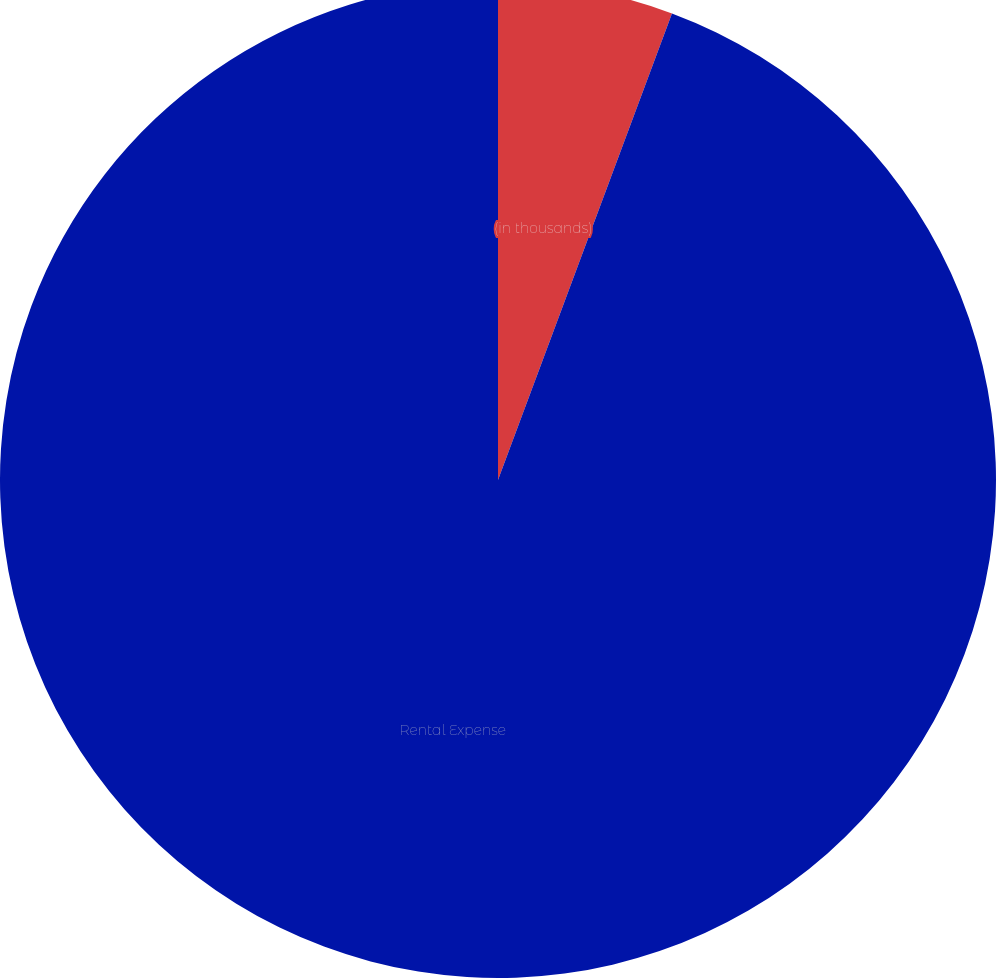<chart> <loc_0><loc_0><loc_500><loc_500><pie_chart><fcel>(in thousands)<fcel>Rental Expense<nl><fcel>5.68%<fcel>94.32%<nl></chart> 